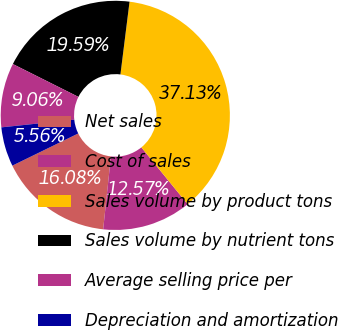Convert chart to OTSL. <chart><loc_0><loc_0><loc_500><loc_500><pie_chart><fcel>Net sales<fcel>Cost of sales<fcel>Sales volume by product tons<fcel>Sales volume by nutrient tons<fcel>Average selling price per<fcel>Depreciation and amortization<nl><fcel>16.08%<fcel>12.57%<fcel>37.13%<fcel>19.59%<fcel>9.06%<fcel>5.56%<nl></chart> 